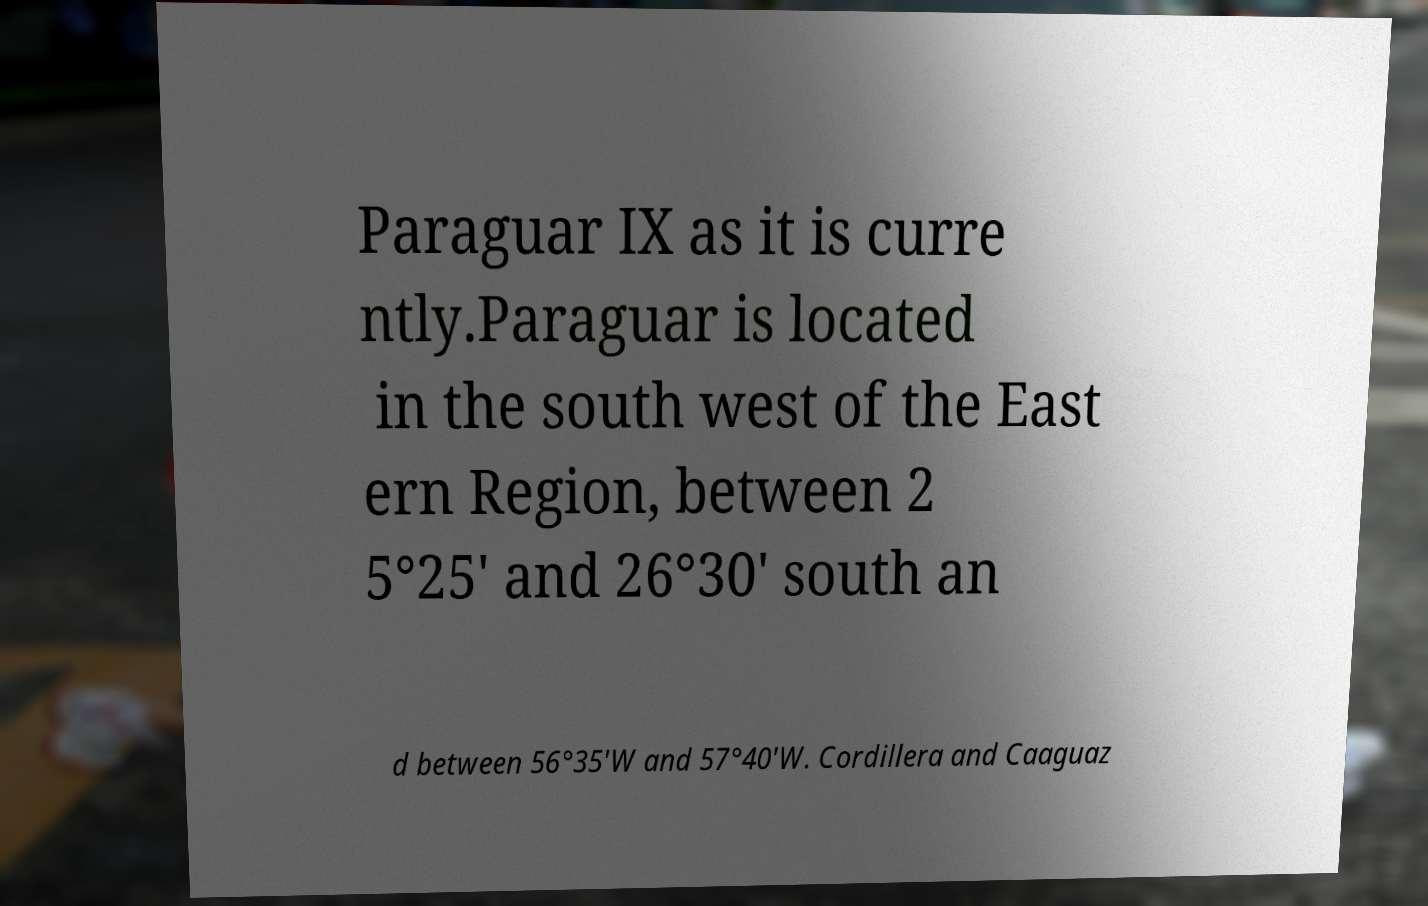There's text embedded in this image that I need extracted. Can you transcribe it verbatim? Paraguar IX as it is curre ntly.Paraguar is located in the south west of the East ern Region, between 2 5°25′ and 26°30′ south an d between 56°35′W and 57°40′W. Cordillera and Caaguaz 